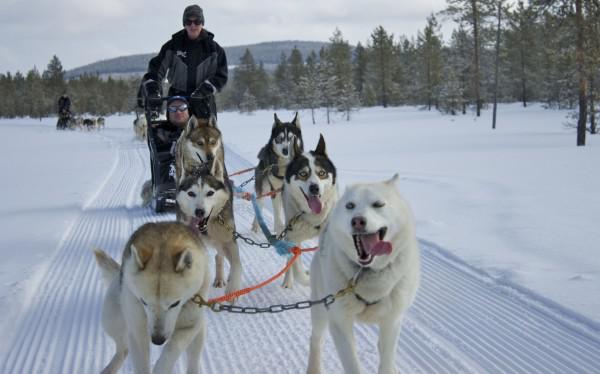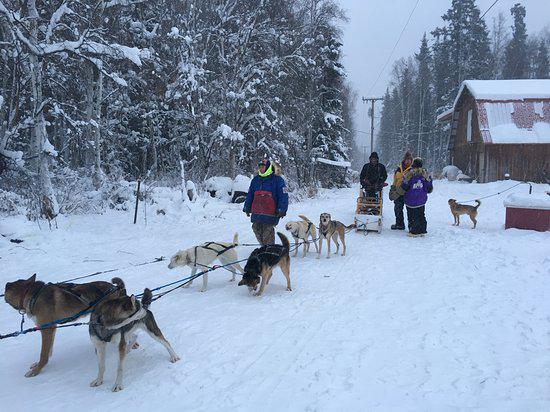The first image is the image on the left, the second image is the image on the right. Analyze the images presented: Is the assertion "A dog team led by two dark dogs is racing rightward and pulling a sled with at least one passenger." valid? Answer yes or no. No. The first image is the image on the left, the second image is the image on the right. Examine the images to the left and right. Is the description "In at least one image there are two adults once laying in the sled and the other holding on as at least six dogs are running right." accurate? Answer yes or no. No. 